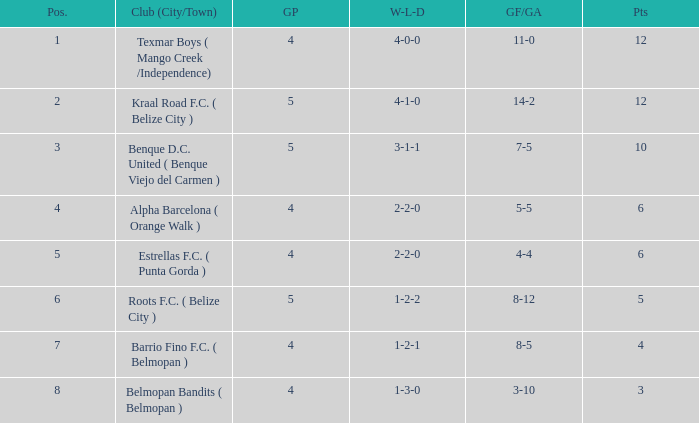What's the w-l-d with position being 1 4-0-0. 